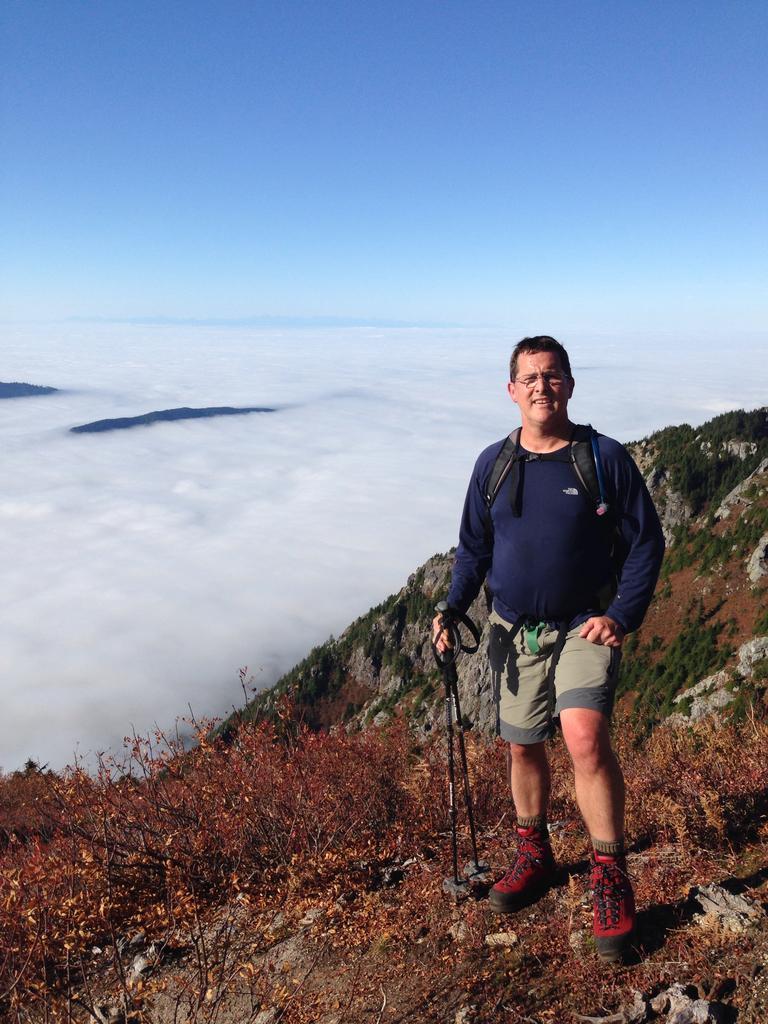Can you describe this image briefly? In this image we can see the person standing and holding sticks and there are plants and grass. Beside the rock we can see the water and the sky. 